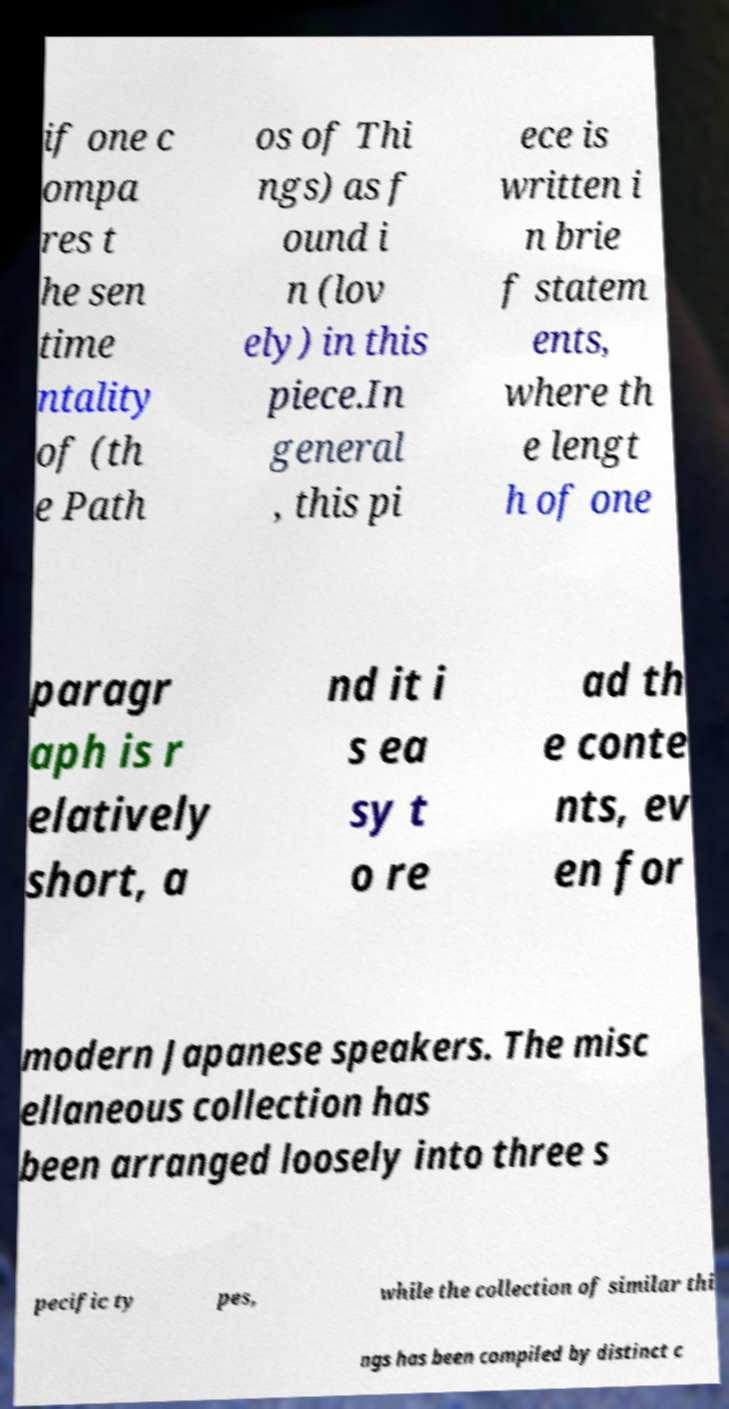What messages or text are displayed in this image? I need them in a readable, typed format. if one c ompa res t he sen time ntality of (th e Path os of Thi ngs) as f ound i n (lov ely) in this piece.In general , this pi ece is written i n brie f statem ents, where th e lengt h of one paragr aph is r elatively short, a nd it i s ea sy t o re ad th e conte nts, ev en for modern Japanese speakers. The misc ellaneous collection has been arranged loosely into three s pecific ty pes, while the collection of similar thi ngs has been compiled by distinct c 